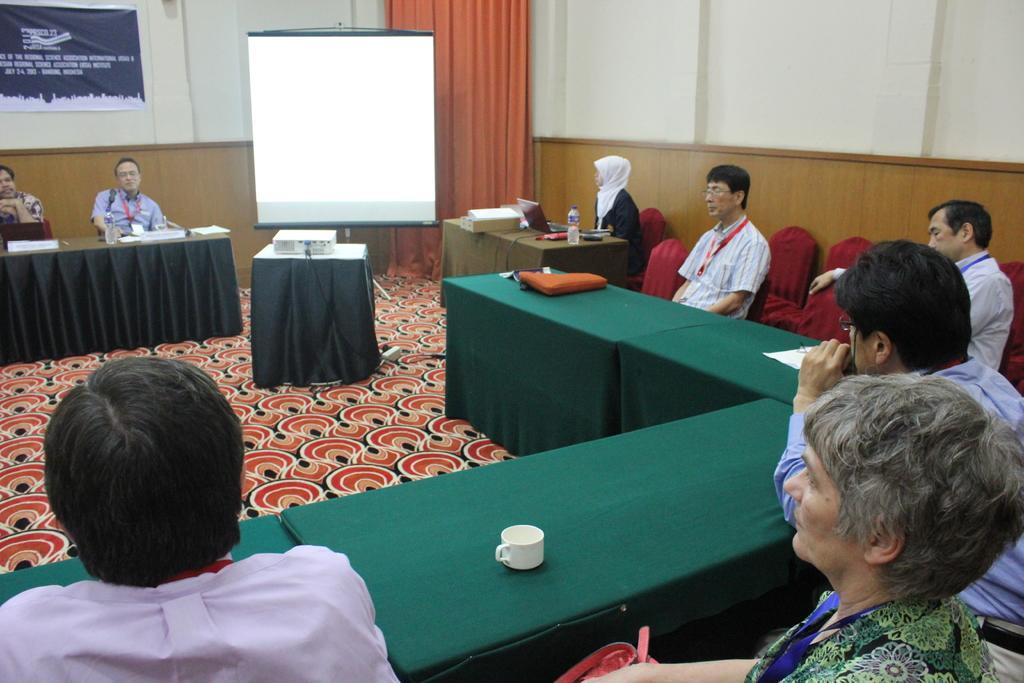How would you summarize this image in a sentence or two? A picture of a inside room. This is screen. In-front of this screen there is a table, on a table there is a projector. This persons are sitting on a chair. In-front of them there are tables. On a table there is a cup, paper, bottle, laptop and file. Poster on wall. Curtain is in orange color. 